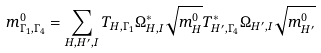<formula> <loc_0><loc_0><loc_500><loc_500>m ^ { 0 } _ { \Gamma _ { 1 } , \Gamma _ { 4 } } = \sum _ { H , H ^ { \prime } , I } T _ { H , \Gamma _ { 1 } } \Omega ^ { * } _ { H , I } \sqrt { m ^ { 0 } _ { H } } T _ { H ^ { \prime } , \Gamma _ { 4 } } ^ { * } \Omega _ { H ^ { \prime } , I } \sqrt { m ^ { 0 } _ { H ^ { \prime } } }</formula> 